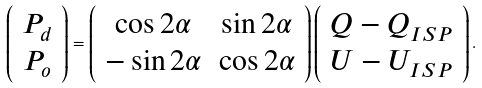Convert formula to latex. <formula><loc_0><loc_0><loc_500><loc_500>\left ( \begin{array} { c } P _ { d } \\ P _ { o } \end{array} \right ) = \left ( \begin{array} { c c } \cos 2 \alpha & \sin 2 \alpha \\ - \sin 2 \alpha & \cos 2 \alpha \\ \end{array} \right ) \left ( \begin{array} { c } Q - Q _ { I S P } \\ U - U _ { I S P } \end{array} \right ) .</formula> 